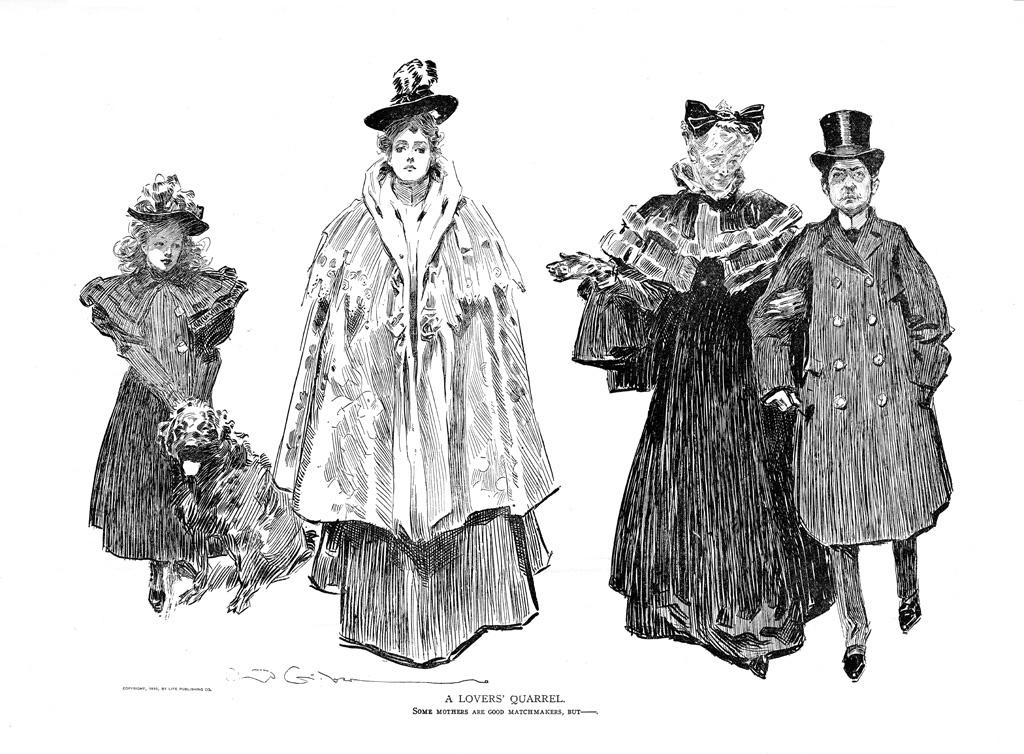What is the main subject of the drawing in the image? The main subject of the drawing in the image is four persons. What are the persons wearing in the drawing? Each person in the drawing is wearing a hat. Are there any animals depicted in the drawing? Yes, there is a drawing of a dog in the image. What can be found at the bottom of the image? There is text written at the bottom of the image. How many beetles can be seen crawling on the persons' hats in the image? There are no beetles present in the image; the persons are wearing hats, but no insects are depicted. Can you tell me the name of the son in the drawing? There is no mention of a son or any names in the image; it only contains a drawing of four persons and a dog. 